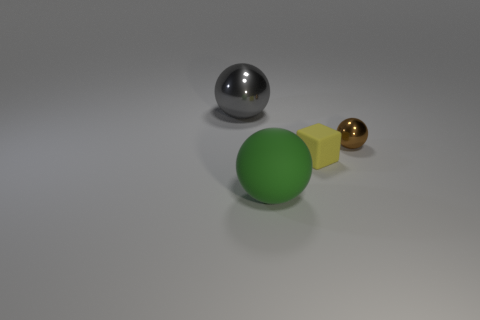The other metallic thing that is the same shape as the big gray metallic thing is what size?
Ensure brevity in your answer.  Small. What is the large gray object made of?
Provide a succinct answer. Metal. There is a tiny thing behind the tiny yellow object to the right of the large green ball that is to the right of the gray metal sphere; what is it made of?
Your answer should be compact. Metal. Is the size of the ball on the right side of the large green matte object the same as the thing left of the large matte object?
Ensure brevity in your answer.  No. What number of other objects are there of the same material as the small brown thing?
Your response must be concise. 1. What number of shiny objects are either yellow objects or gray things?
Make the answer very short. 1. Is the number of rubber things less than the number of things?
Give a very brief answer. Yes. Is the size of the green rubber ball the same as the metallic sphere on the left side of the tiny metallic thing?
Offer a very short reply. Yes. Is there anything else that is the same shape as the tiny rubber thing?
Provide a succinct answer. No. What is the size of the yellow matte cube?
Provide a succinct answer. Small. 